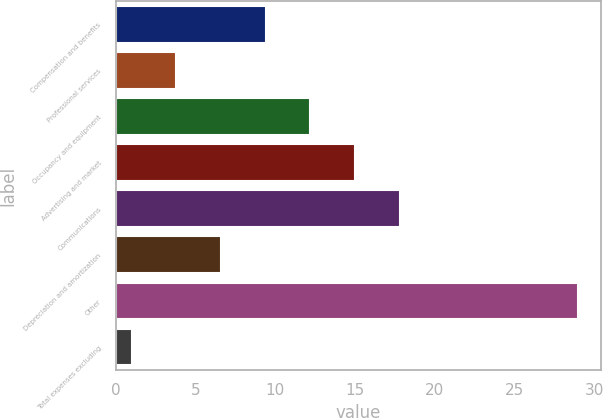<chart> <loc_0><loc_0><loc_500><loc_500><bar_chart><fcel>Compensation and benefits<fcel>Professional services<fcel>Occupancy and equipment<fcel>Advertising and market<fcel>Communications<fcel>Depreciation and amortization<fcel>Other<fcel>Total expenses excluding<nl><fcel>9.4<fcel>3.8<fcel>12.2<fcel>15<fcel>17.8<fcel>6.6<fcel>29<fcel>1<nl></chart> 